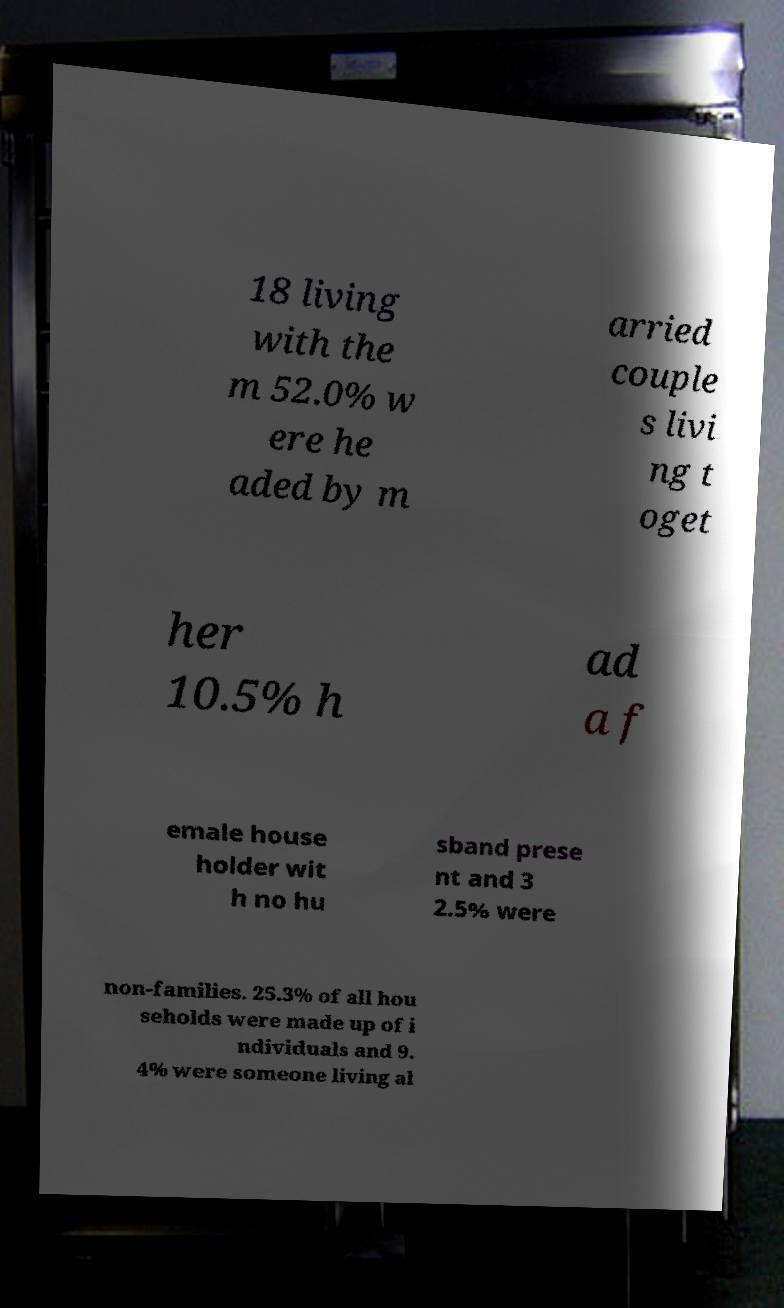Please identify and transcribe the text found in this image. 18 living with the m 52.0% w ere he aded by m arried couple s livi ng t oget her 10.5% h ad a f emale house holder wit h no hu sband prese nt and 3 2.5% were non-families. 25.3% of all hou seholds were made up of i ndividuals and 9. 4% were someone living al 